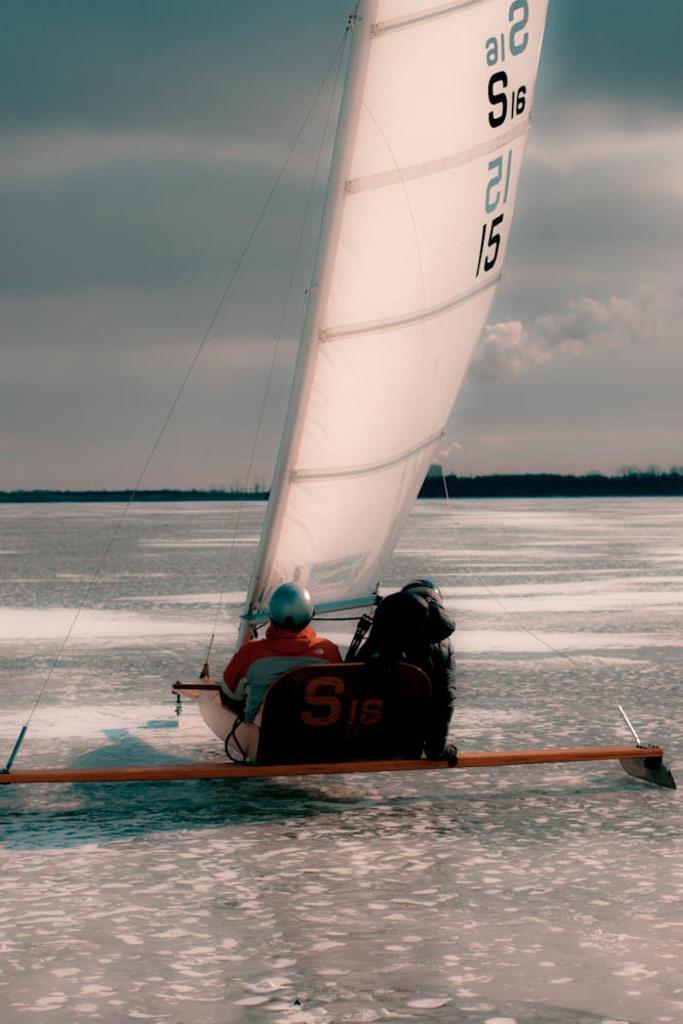In one or two sentences, can you explain what this image depicts? In this picture I can see there are two persons sitting on a skate board and there is ice on the floor and in the backdrop there are trees and the sky is clear. 